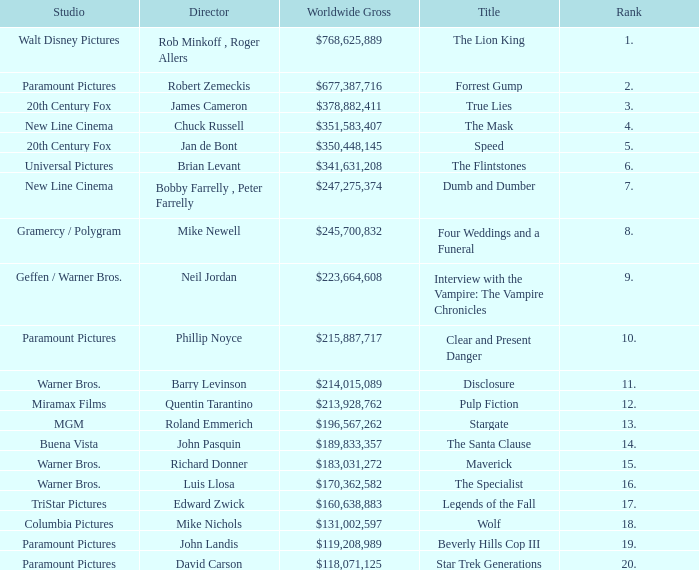What is the Worldwide Gross of the Film with a Rank of 3? $378,882,411. 